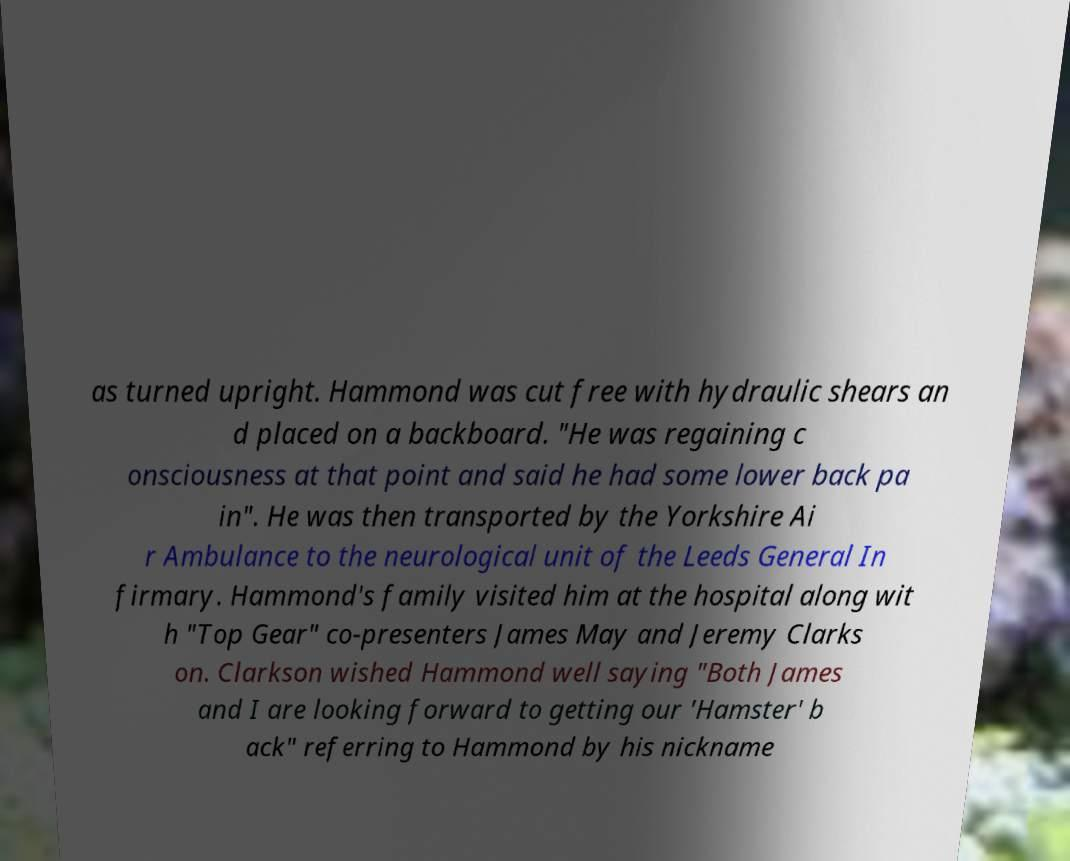For documentation purposes, I need the text within this image transcribed. Could you provide that? as turned upright. Hammond was cut free with hydraulic shears an d placed on a backboard. "He was regaining c onsciousness at that point and said he had some lower back pa in". He was then transported by the Yorkshire Ai r Ambulance to the neurological unit of the Leeds General In firmary. Hammond's family visited him at the hospital along wit h "Top Gear" co-presenters James May and Jeremy Clarks on. Clarkson wished Hammond well saying "Both James and I are looking forward to getting our 'Hamster' b ack" referring to Hammond by his nickname 